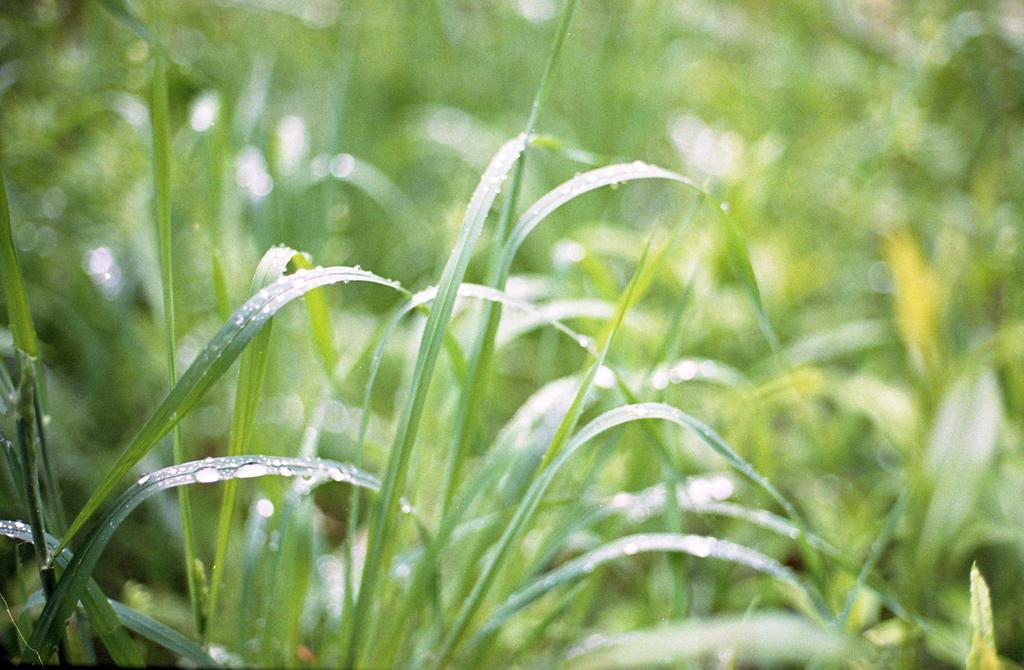What type of vegetation can be seen in the image? There is grass in the image. Are there any visible signs of moisture on the grass? Yes, there are water droplets on the grass. What type of corn is growing in the image? There is no corn present in the image; it only features grass with water droplets. 